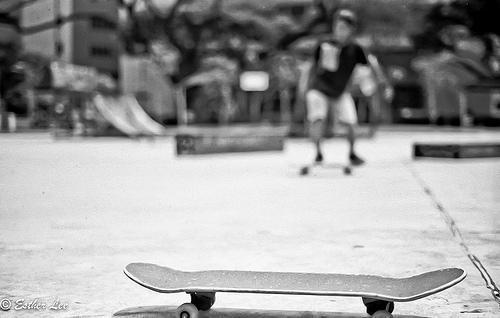How many people are in the picture?
Give a very brief answer. 1. 